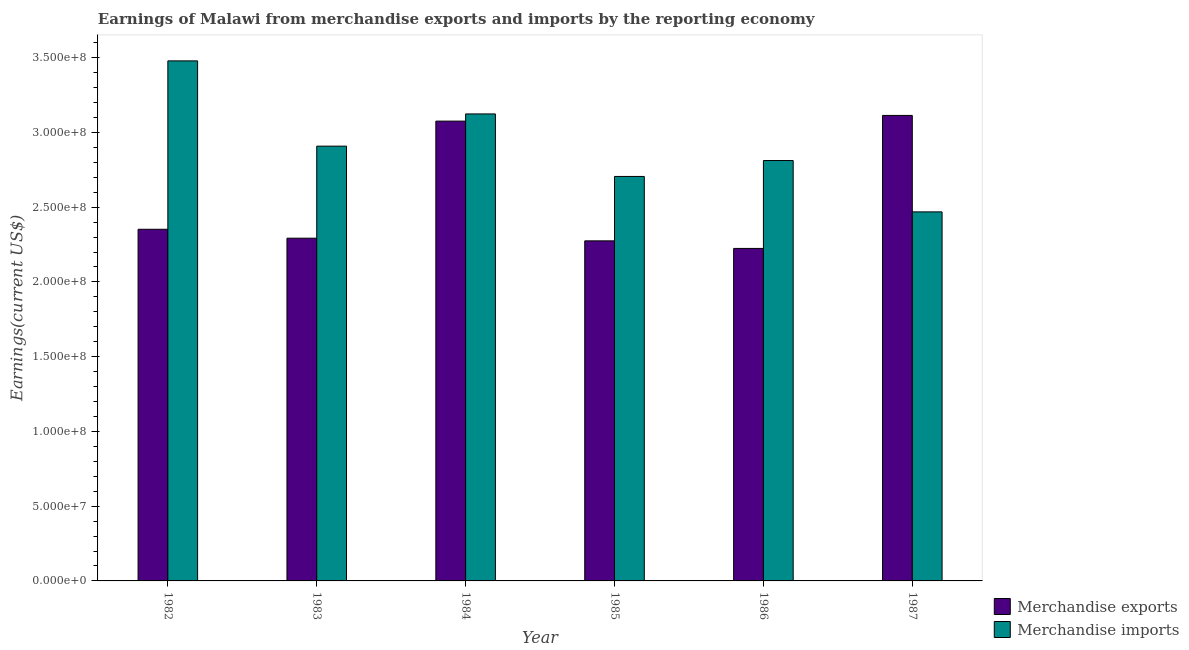How many different coloured bars are there?
Provide a succinct answer. 2. How many groups of bars are there?
Offer a terse response. 6. How many bars are there on the 6th tick from the left?
Offer a terse response. 2. In how many cases, is the number of bars for a given year not equal to the number of legend labels?
Ensure brevity in your answer.  0. What is the earnings from merchandise imports in 1983?
Ensure brevity in your answer.  2.91e+08. Across all years, what is the maximum earnings from merchandise imports?
Provide a succinct answer. 3.48e+08. Across all years, what is the minimum earnings from merchandise imports?
Make the answer very short. 2.47e+08. In which year was the earnings from merchandise imports maximum?
Keep it short and to the point. 1982. What is the total earnings from merchandise exports in the graph?
Provide a short and direct response. 1.53e+09. What is the difference between the earnings from merchandise exports in 1982 and that in 1985?
Ensure brevity in your answer.  7.75e+06. What is the difference between the earnings from merchandise imports in 1986 and the earnings from merchandise exports in 1982?
Offer a very short reply. -6.67e+07. What is the average earnings from merchandise imports per year?
Ensure brevity in your answer.  2.92e+08. In the year 1986, what is the difference between the earnings from merchandise imports and earnings from merchandise exports?
Give a very brief answer. 0. What is the ratio of the earnings from merchandise exports in 1983 to that in 1985?
Offer a terse response. 1.01. Is the earnings from merchandise imports in 1984 less than that in 1986?
Your answer should be very brief. No. Is the difference between the earnings from merchandise imports in 1982 and 1987 greater than the difference between the earnings from merchandise exports in 1982 and 1987?
Give a very brief answer. No. What is the difference between the highest and the second highest earnings from merchandise imports?
Provide a short and direct response. 3.55e+07. What is the difference between the highest and the lowest earnings from merchandise exports?
Your answer should be very brief. 8.90e+07. What does the 2nd bar from the left in 1982 represents?
Your response must be concise. Merchandise imports. How many bars are there?
Ensure brevity in your answer.  12. Are all the bars in the graph horizontal?
Offer a terse response. No. Are the values on the major ticks of Y-axis written in scientific E-notation?
Offer a very short reply. Yes. Does the graph contain any zero values?
Your answer should be compact. No. Does the graph contain grids?
Your answer should be very brief. No. Where does the legend appear in the graph?
Make the answer very short. Bottom right. How are the legend labels stacked?
Provide a succinct answer. Vertical. What is the title of the graph?
Give a very brief answer. Earnings of Malawi from merchandise exports and imports by the reporting economy. What is the label or title of the Y-axis?
Provide a succinct answer. Earnings(current US$). What is the Earnings(current US$) in Merchandise exports in 1982?
Provide a succinct answer. 2.35e+08. What is the Earnings(current US$) in Merchandise imports in 1982?
Give a very brief answer. 3.48e+08. What is the Earnings(current US$) of Merchandise exports in 1983?
Make the answer very short. 2.29e+08. What is the Earnings(current US$) in Merchandise imports in 1983?
Give a very brief answer. 2.91e+08. What is the Earnings(current US$) of Merchandise exports in 1984?
Ensure brevity in your answer.  3.08e+08. What is the Earnings(current US$) of Merchandise imports in 1984?
Offer a terse response. 3.12e+08. What is the Earnings(current US$) of Merchandise exports in 1985?
Offer a very short reply. 2.27e+08. What is the Earnings(current US$) of Merchandise imports in 1985?
Your response must be concise. 2.71e+08. What is the Earnings(current US$) of Merchandise exports in 1986?
Provide a succinct answer. 2.22e+08. What is the Earnings(current US$) of Merchandise imports in 1986?
Keep it short and to the point. 2.81e+08. What is the Earnings(current US$) of Merchandise exports in 1987?
Give a very brief answer. 3.11e+08. What is the Earnings(current US$) of Merchandise imports in 1987?
Provide a succinct answer. 2.47e+08. Across all years, what is the maximum Earnings(current US$) of Merchandise exports?
Your answer should be compact. 3.11e+08. Across all years, what is the maximum Earnings(current US$) in Merchandise imports?
Ensure brevity in your answer.  3.48e+08. Across all years, what is the minimum Earnings(current US$) in Merchandise exports?
Offer a very short reply. 2.22e+08. Across all years, what is the minimum Earnings(current US$) in Merchandise imports?
Make the answer very short. 2.47e+08. What is the total Earnings(current US$) in Merchandise exports in the graph?
Ensure brevity in your answer.  1.53e+09. What is the total Earnings(current US$) of Merchandise imports in the graph?
Your response must be concise. 1.75e+09. What is the difference between the Earnings(current US$) in Merchandise exports in 1982 and that in 1983?
Offer a very short reply. 5.97e+06. What is the difference between the Earnings(current US$) in Merchandise imports in 1982 and that in 1983?
Provide a succinct answer. 5.70e+07. What is the difference between the Earnings(current US$) of Merchandise exports in 1982 and that in 1984?
Offer a very short reply. -7.23e+07. What is the difference between the Earnings(current US$) of Merchandise imports in 1982 and that in 1984?
Provide a succinct answer. 3.55e+07. What is the difference between the Earnings(current US$) of Merchandise exports in 1982 and that in 1985?
Make the answer very short. 7.75e+06. What is the difference between the Earnings(current US$) of Merchandise imports in 1982 and that in 1985?
Provide a succinct answer. 7.73e+07. What is the difference between the Earnings(current US$) of Merchandise exports in 1982 and that in 1986?
Provide a succinct answer. 1.28e+07. What is the difference between the Earnings(current US$) in Merchandise imports in 1982 and that in 1986?
Offer a terse response. 6.67e+07. What is the difference between the Earnings(current US$) of Merchandise exports in 1982 and that in 1987?
Keep it short and to the point. -7.61e+07. What is the difference between the Earnings(current US$) in Merchandise imports in 1982 and that in 1987?
Your answer should be compact. 1.01e+08. What is the difference between the Earnings(current US$) in Merchandise exports in 1983 and that in 1984?
Make the answer very short. -7.83e+07. What is the difference between the Earnings(current US$) of Merchandise imports in 1983 and that in 1984?
Your answer should be very brief. -2.15e+07. What is the difference between the Earnings(current US$) of Merchandise exports in 1983 and that in 1985?
Offer a terse response. 1.78e+06. What is the difference between the Earnings(current US$) of Merchandise imports in 1983 and that in 1985?
Give a very brief answer. 2.03e+07. What is the difference between the Earnings(current US$) of Merchandise exports in 1983 and that in 1986?
Provide a succinct answer. 6.85e+06. What is the difference between the Earnings(current US$) of Merchandise imports in 1983 and that in 1986?
Ensure brevity in your answer.  9.63e+06. What is the difference between the Earnings(current US$) in Merchandise exports in 1983 and that in 1987?
Provide a short and direct response. -8.21e+07. What is the difference between the Earnings(current US$) of Merchandise imports in 1983 and that in 1987?
Give a very brief answer. 4.40e+07. What is the difference between the Earnings(current US$) in Merchandise exports in 1984 and that in 1985?
Provide a short and direct response. 8.01e+07. What is the difference between the Earnings(current US$) in Merchandise imports in 1984 and that in 1985?
Your answer should be compact. 4.18e+07. What is the difference between the Earnings(current US$) of Merchandise exports in 1984 and that in 1986?
Provide a succinct answer. 8.52e+07. What is the difference between the Earnings(current US$) in Merchandise imports in 1984 and that in 1986?
Your response must be concise. 3.12e+07. What is the difference between the Earnings(current US$) in Merchandise exports in 1984 and that in 1987?
Ensure brevity in your answer.  -3.80e+06. What is the difference between the Earnings(current US$) of Merchandise imports in 1984 and that in 1987?
Keep it short and to the point. 6.55e+07. What is the difference between the Earnings(current US$) of Merchandise exports in 1985 and that in 1986?
Your answer should be compact. 5.07e+06. What is the difference between the Earnings(current US$) of Merchandise imports in 1985 and that in 1986?
Offer a terse response. -1.06e+07. What is the difference between the Earnings(current US$) in Merchandise exports in 1985 and that in 1987?
Keep it short and to the point. -8.39e+07. What is the difference between the Earnings(current US$) in Merchandise imports in 1985 and that in 1987?
Keep it short and to the point. 2.37e+07. What is the difference between the Earnings(current US$) of Merchandise exports in 1986 and that in 1987?
Give a very brief answer. -8.90e+07. What is the difference between the Earnings(current US$) in Merchandise imports in 1986 and that in 1987?
Your answer should be very brief. 3.43e+07. What is the difference between the Earnings(current US$) in Merchandise exports in 1982 and the Earnings(current US$) in Merchandise imports in 1983?
Make the answer very short. -5.56e+07. What is the difference between the Earnings(current US$) in Merchandise exports in 1982 and the Earnings(current US$) in Merchandise imports in 1984?
Give a very brief answer. -7.71e+07. What is the difference between the Earnings(current US$) of Merchandise exports in 1982 and the Earnings(current US$) of Merchandise imports in 1985?
Keep it short and to the point. -3.53e+07. What is the difference between the Earnings(current US$) of Merchandise exports in 1982 and the Earnings(current US$) of Merchandise imports in 1986?
Keep it short and to the point. -4.60e+07. What is the difference between the Earnings(current US$) of Merchandise exports in 1982 and the Earnings(current US$) of Merchandise imports in 1987?
Ensure brevity in your answer.  -1.16e+07. What is the difference between the Earnings(current US$) of Merchandise exports in 1983 and the Earnings(current US$) of Merchandise imports in 1984?
Your response must be concise. -8.31e+07. What is the difference between the Earnings(current US$) in Merchandise exports in 1983 and the Earnings(current US$) in Merchandise imports in 1985?
Keep it short and to the point. -4.13e+07. What is the difference between the Earnings(current US$) of Merchandise exports in 1983 and the Earnings(current US$) of Merchandise imports in 1986?
Offer a terse response. -5.19e+07. What is the difference between the Earnings(current US$) of Merchandise exports in 1983 and the Earnings(current US$) of Merchandise imports in 1987?
Ensure brevity in your answer.  -1.76e+07. What is the difference between the Earnings(current US$) of Merchandise exports in 1984 and the Earnings(current US$) of Merchandise imports in 1985?
Your answer should be compact. 3.70e+07. What is the difference between the Earnings(current US$) in Merchandise exports in 1984 and the Earnings(current US$) in Merchandise imports in 1986?
Keep it short and to the point. 2.64e+07. What is the difference between the Earnings(current US$) in Merchandise exports in 1984 and the Earnings(current US$) in Merchandise imports in 1987?
Give a very brief answer. 6.07e+07. What is the difference between the Earnings(current US$) of Merchandise exports in 1985 and the Earnings(current US$) of Merchandise imports in 1986?
Offer a very short reply. -5.37e+07. What is the difference between the Earnings(current US$) of Merchandise exports in 1985 and the Earnings(current US$) of Merchandise imports in 1987?
Ensure brevity in your answer.  -1.94e+07. What is the difference between the Earnings(current US$) in Merchandise exports in 1986 and the Earnings(current US$) in Merchandise imports in 1987?
Give a very brief answer. -2.45e+07. What is the average Earnings(current US$) in Merchandise exports per year?
Provide a short and direct response. 2.56e+08. What is the average Earnings(current US$) of Merchandise imports per year?
Provide a succinct answer. 2.92e+08. In the year 1982, what is the difference between the Earnings(current US$) in Merchandise exports and Earnings(current US$) in Merchandise imports?
Offer a terse response. -1.13e+08. In the year 1983, what is the difference between the Earnings(current US$) in Merchandise exports and Earnings(current US$) in Merchandise imports?
Provide a short and direct response. -6.16e+07. In the year 1984, what is the difference between the Earnings(current US$) in Merchandise exports and Earnings(current US$) in Merchandise imports?
Offer a terse response. -4.80e+06. In the year 1985, what is the difference between the Earnings(current US$) of Merchandise exports and Earnings(current US$) of Merchandise imports?
Provide a succinct answer. -4.31e+07. In the year 1986, what is the difference between the Earnings(current US$) of Merchandise exports and Earnings(current US$) of Merchandise imports?
Provide a succinct answer. -5.88e+07. In the year 1987, what is the difference between the Earnings(current US$) in Merchandise exports and Earnings(current US$) in Merchandise imports?
Keep it short and to the point. 6.45e+07. What is the ratio of the Earnings(current US$) of Merchandise exports in 1982 to that in 1983?
Offer a very short reply. 1.03. What is the ratio of the Earnings(current US$) of Merchandise imports in 1982 to that in 1983?
Ensure brevity in your answer.  1.2. What is the ratio of the Earnings(current US$) of Merchandise exports in 1982 to that in 1984?
Your answer should be compact. 0.76. What is the ratio of the Earnings(current US$) of Merchandise imports in 1982 to that in 1984?
Your answer should be compact. 1.11. What is the ratio of the Earnings(current US$) of Merchandise exports in 1982 to that in 1985?
Make the answer very short. 1.03. What is the ratio of the Earnings(current US$) of Merchandise imports in 1982 to that in 1985?
Your answer should be compact. 1.29. What is the ratio of the Earnings(current US$) in Merchandise exports in 1982 to that in 1986?
Offer a terse response. 1.06. What is the ratio of the Earnings(current US$) of Merchandise imports in 1982 to that in 1986?
Your answer should be very brief. 1.24. What is the ratio of the Earnings(current US$) of Merchandise exports in 1982 to that in 1987?
Offer a very short reply. 0.76. What is the ratio of the Earnings(current US$) in Merchandise imports in 1982 to that in 1987?
Your response must be concise. 1.41. What is the ratio of the Earnings(current US$) in Merchandise exports in 1983 to that in 1984?
Offer a very short reply. 0.75. What is the ratio of the Earnings(current US$) in Merchandise imports in 1983 to that in 1985?
Give a very brief answer. 1.07. What is the ratio of the Earnings(current US$) of Merchandise exports in 1983 to that in 1986?
Offer a terse response. 1.03. What is the ratio of the Earnings(current US$) in Merchandise imports in 1983 to that in 1986?
Make the answer very short. 1.03. What is the ratio of the Earnings(current US$) in Merchandise exports in 1983 to that in 1987?
Your answer should be very brief. 0.74. What is the ratio of the Earnings(current US$) of Merchandise imports in 1983 to that in 1987?
Make the answer very short. 1.18. What is the ratio of the Earnings(current US$) in Merchandise exports in 1984 to that in 1985?
Provide a succinct answer. 1.35. What is the ratio of the Earnings(current US$) in Merchandise imports in 1984 to that in 1985?
Your answer should be compact. 1.15. What is the ratio of the Earnings(current US$) in Merchandise exports in 1984 to that in 1986?
Your answer should be very brief. 1.38. What is the ratio of the Earnings(current US$) of Merchandise imports in 1984 to that in 1986?
Offer a very short reply. 1.11. What is the ratio of the Earnings(current US$) of Merchandise imports in 1984 to that in 1987?
Give a very brief answer. 1.27. What is the ratio of the Earnings(current US$) of Merchandise exports in 1985 to that in 1986?
Your answer should be compact. 1.02. What is the ratio of the Earnings(current US$) of Merchandise imports in 1985 to that in 1986?
Your response must be concise. 0.96. What is the ratio of the Earnings(current US$) of Merchandise exports in 1985 to that in 1987?
Your answer should be compact. 0.73. What is the ratio of the Earnings(current US$) of Merchandise imports in 1985 to that in 1987?
Ensure brevity in your answer.  1.1. What is the ratio of the Earnings(current US$) of Merchandise imports in 1986 to that in 1987?
Ensure brevity in your answer.  1.14. What is the difference between the highest and the second highest Earnings(current US$) of Merchandise exports?
Ensure brevity in your answer.  3.80e+06. What is the difference between the highest and the second highest Earnings(current US$) in Merchandise imports?
Offer a very short reply. 3.55e+07. What is the difference between the highest and the lowest Earnings(current US$) of Merchandise exports?
Give a very brief answer. 8.90e+07. What is the difference between the highest and the lowest Earnings(current US$) of Merchandise imports?
Provide a succinct answer. 1.01e+08. 